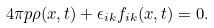Convert formula to latex. <formula><loc_0><loc_0><loc_500><loc_500>4 \pi p \rho ( x , t ) + \epsilon _ { i k } f _ { i k } ( x , t ) = 0 .</formula> 